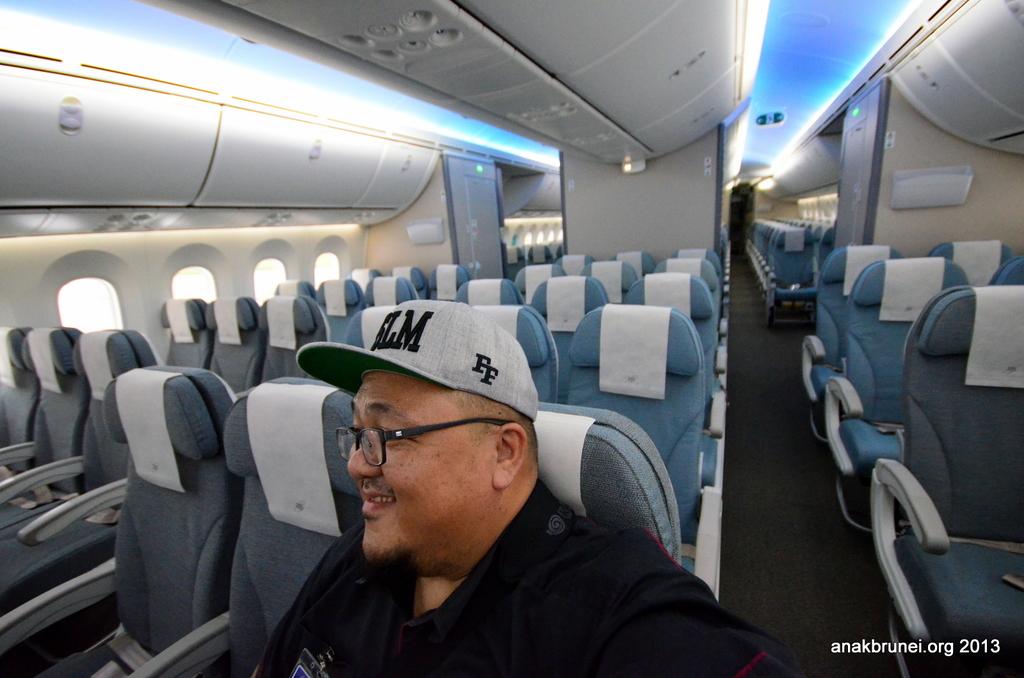What is on the side of the hat?
Ensure brevity in your answer.  Ff. What is the website on the corner of the picture?
Offer a terse response. Anakbrunei.org. 